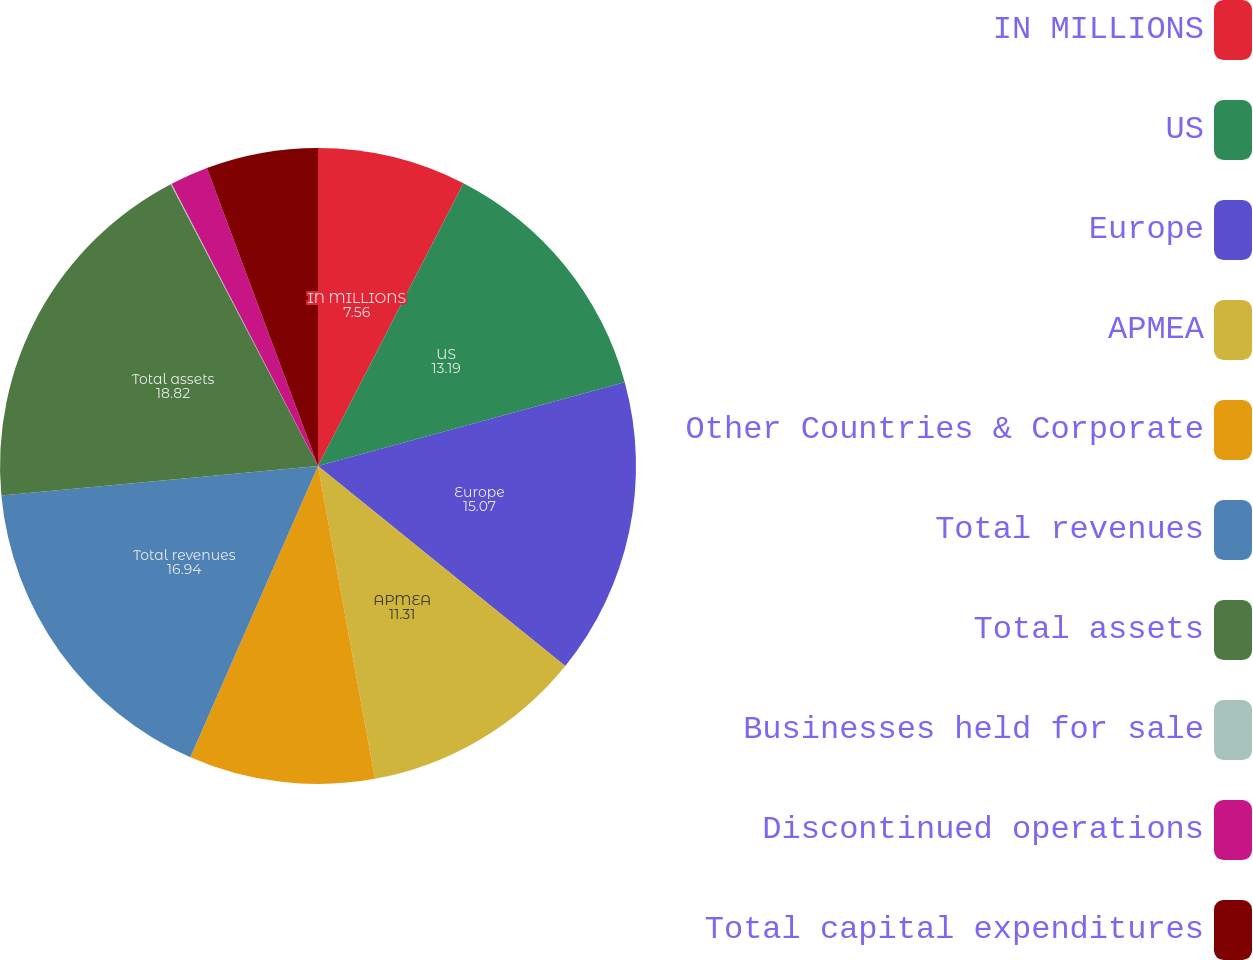Convert chart to OTSL. <chart><loc_0><loc_0><loc_500><loc_500><pie_chart><fcel>IN MILLIONS<fcel>US<fcel>Europe<fcel>APMEA<fcel>Other Countries & Corporate<fcel>Total revenues<fcel>Total assets<fcel>Businesses held for sale<fcel>Discontinued operations<fcel>Total capital expenditures<nl><fcel>7.56%<fcel>13.19%<fcel>15.07%<fcel>11.31%<fcel>9.44%<fcel>16.94%<fcel>18.82%<fcel>0.05%<fcel>1.93%<fcel>5.68%<nl></chart> 